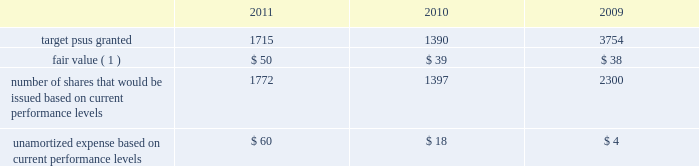Performance share awards the vesting of psas is contingent upon meeting various individual , divisional or company-wide performance conditions , including revenue generation or growth in revenue , pretax income or earnings per share over a one- to five-year period .
The performance conditions are not considered in the determination of the grant date fair value for these awards .
The fair value of psas is based upon the market price of the aon common stock at the date of grant .
Compensation expense is recognized over the performance period , and in certain cases an additional vesting period , based on management 2019s estimate of the number of units expected to vest .
Compensation expense is adjusted to reflect the actual number of shares issued at the end of the programs .
The actual issuance of shares may range from 0-200% ( 0-200 % ) of the target number of psas granted , based on the plan .
Dividend equivalents are not paid on psas .
Information regarding psas granted during the years ended december 31 , 2011 , 2010 and 2009 follows ( shares in thousands , dollars in millions , except fair value ) : .
( 1 ) represents per share weighted average fair value of award at date of grant .
During 2011 , the company issued approximately 1.2 million shares in connection with the 2008 leadership performance plan ( 2018 2018lpp 2019 2019 ) cycle and 0.3 million shares related to a 2006 performance plan .
During 2010 , the company issued approximately 1.6 million shares in connection with the completion of the 2007 lpp cycle and 84000 shares related to other performance plans .
Stock options options to purchase common stock are granted to certain employees at fair value on the date of grant .
Commencing in 2010 , the company ceased granting new stock options with the exception of historical contractual commitments .
Generally , employees are required to complete two continuous years of service before the options begin to vest in increments until the completion of a 4-year period of continuous employment , although a number of options were granted that require five continuous years of service before the options are fully vested .
Options issued under the lpp program vest ratable over 3 years with a six year term .
The maximum contractual term on stock options is generally ten years from the date of grant .
Aon uses a lattice-binomial option-pricing model to value stock options .
Lattice-based option valuation models use a range of assumptions over the expected term of the options .
Expected volatilities are based on the average of the historical volatility of aon 2019s stock price and the implied volatility of traded options and aon 2019s stock .
The valuation model stratifies employees between those receiving lpp options , special stock plan ( 2018 2018ssp 2019 2019 ) options , and all other option grants .
The company believes that this stratification better represents prospective stock option exercise patterns .
The expected dividend yield assumption is based on the company 2019s historical and expected future dividend rate .
The risk-free rate for periods within the contractual life of the option is based on the u.s .
Treasury yield curve in effect at the time of grant .
The expected life of employee stock options represents the weighted-average period stock options are expected to remain outstanding and is a derived output of the lattice-binomial model. .
What was the change in million in the unamortized expense based on current performance levels from 2010 to 2011? 
Rationale: the unamortized expense based on current performance levels increased by 42 million from 2010 to 2011
Computations: (60 - 18)
Answer: 42.0. 